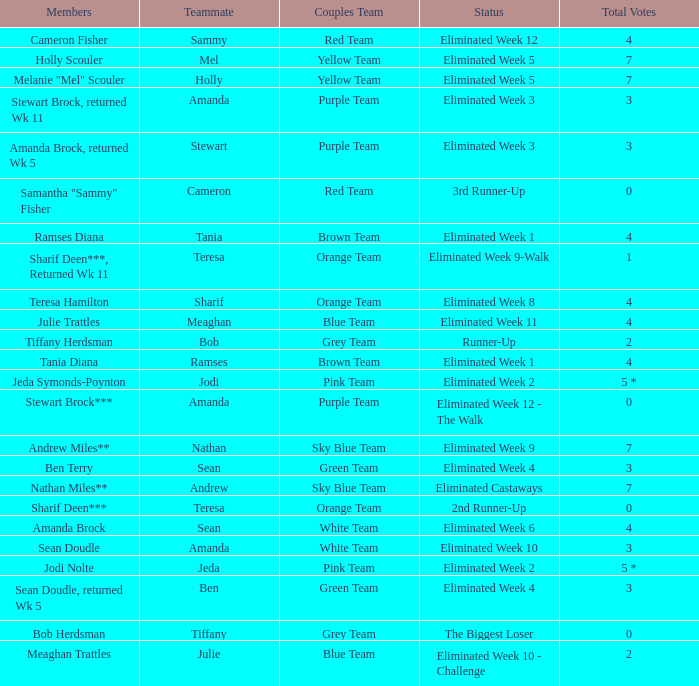Who had 0 total votes in the purple team? Eliminated Week 12 - The Walk. 